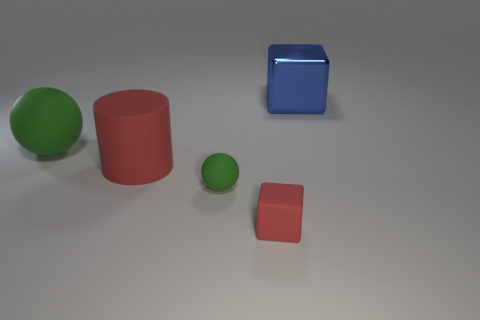How do the textures of the objects compare? The blue cube has a reflective and smooth texture, while the red objects exhibit a matte finish with what appears to be a slightly rough texture. 